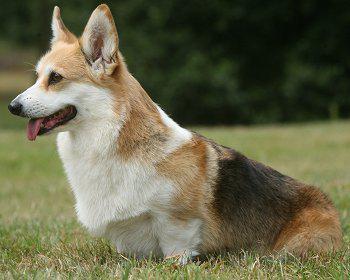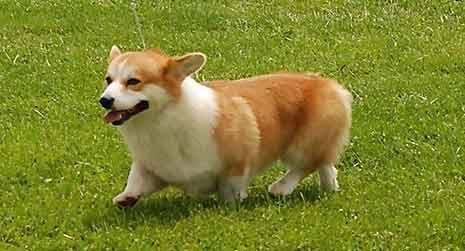The first image is the image on the left, the second image is the image on the right. Evaluate the accuracy of this statement regarding the images: "An image shows a corgi standing in grass with leftward foot raised.". Is it true? Answer yes or no. Yes. 